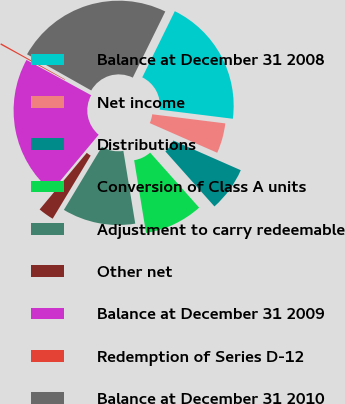Convert chart to OTSL. <chart><loc_0><loc_0><loc_500><loc_500><pie_chart><fcel>Balance at December 31 2008<fcel>Net income<fcel>Distributions<fcel>Conversion of Class A units<fcel>Adjustment to carry redeemable<fcel>Other net<fcel>Balance at December 31 2009<fcel>Redemption of Series D-12<fcel>Balance at December 31 2010<nl><fcel>19.7%<fcel>4.62%<fcel>6.82%<fcel>9.01%<fcel>11.21%<fcel>2.42%<fcel>21.9%<fcel>0.22%<fcel>24.1%<nl></chart> 